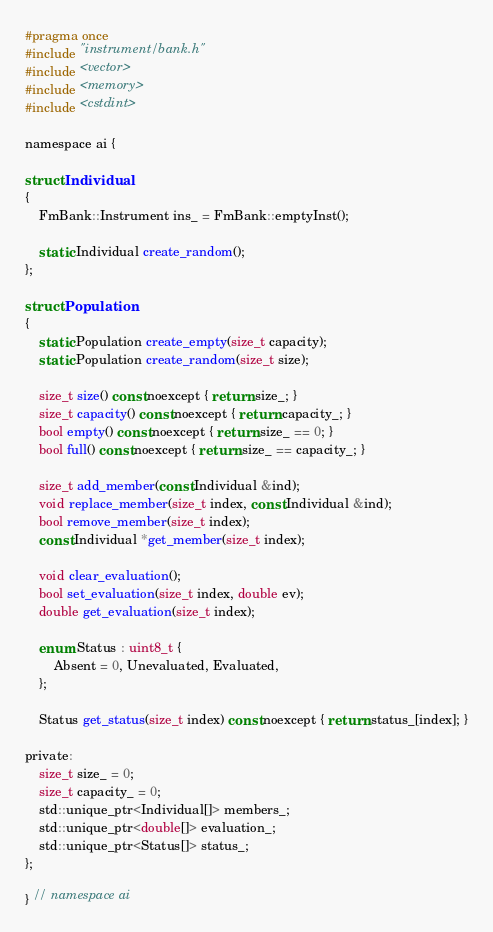Convert code to text. <code><loc_0><loc_0><loc_500><loc_500><_C_>#pragma once
#include "instrument/bank.h"
#include <vector>
#include <memory>
#include <cstdint>

namespace ai {

struct Individual
{
    FmBank::Instrument ins_ = FmBank::emptyInst();

    static Individual create_random();
};

struct Population
{
    static Population create_empty(size_t capacity);
    static Population create_random(size_t size);

    size_t size() const noexcept { return size_; }
    size_t capacity() const noexcept { return capacity_; }
    bool empty() const noexcept { return size_ == 0; }
    bool full() const noexcept { return size_ == capacity_; }

    size_t add_member(const Individual &ind);
    void replace_member(size_t index, const Individual &ind);
    bool remove_member(size_t index);
    const Individual *get_member(size_t index);

    void clear_evaluation();
    bool set_evaluation(size_t index, double ev);
    double get_evaluation(size_t index);

    enum Status : uint8_t {
        Absent = 0, Unevaluated, Evaluated,
    };

    Status get_status(size_t index) const noexcept { return status_[index]; }

private:
    size_t size_ = 0;
    size_t capacity_ = 0;
    std::unique_ptr<Individual[]> members_;
    std::unique_ptr<double[]> evaluation_;
    std::unique_ptr<Status[]> status_;
};

} // namespace ai
</code> 